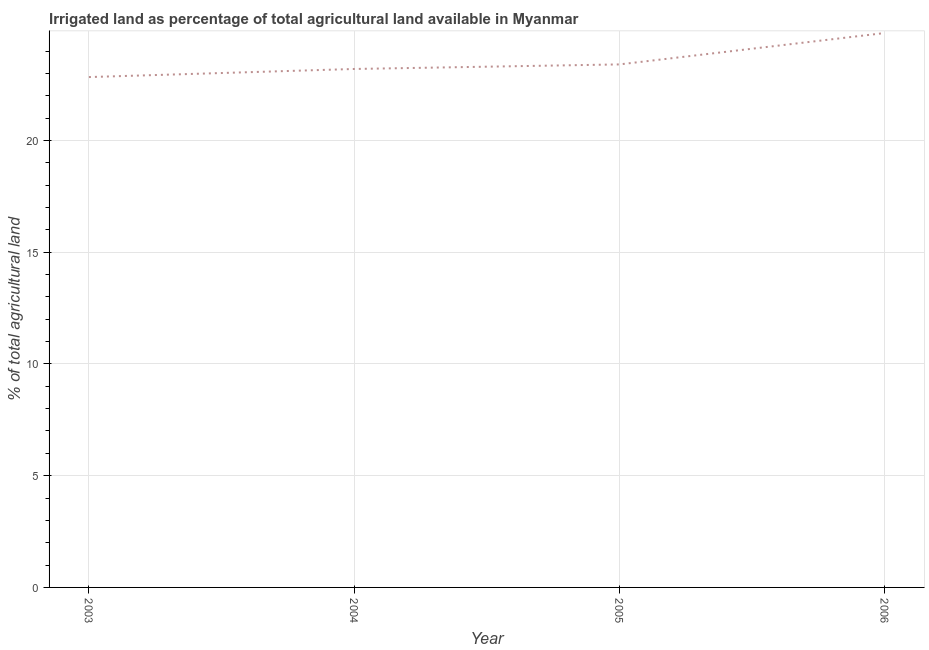What is the percentage of agricultural irrigated land in 2004?
Make the answer very short. 23.2. Across all years, what is the maximum percentage of agricultural irrigated land?
Offer a terse response. 24.81. Across all years, what is the minimum percentage of agricultural irrigated land?
Provide a short and direct response. 22.84. What is the sum of the percentage of agricultural irrigated land?
Ensure brevity in your answer.  94.25. What is the difference between the percentage of agricultural irrigated land in 2004 and 2006?
Offer a terse response. -1.61. What is the average percentage of agricultural irrigated land per year?
Ensure brevity in your answer.  23.56. What is the median percentage of agricultural irrigated land?
Offer a terse response. 23.3. Do a majority of the years between 2004 and 2005 (inclusive) have percentage of agricultural irrigated land greater than 22 %?
Ensure brevity in your answer.  Yes. What is the ratio of the percentage of agricultural irrigated land in 2003 to that in 2004?
Your answer should be compact. 0.98. Is the difference between the percentage of agricultural irrigated land in 2003 and 2004 greater than the difference between any two years?
Your answer should be very brief. No. What is the difference between the highest and the second highest percentage of agricultural irrigated land?
Your answer should be very brief. 1.4. What is the difference between the highest and the lowest percentage of agricultural irrigated land?
Your answer should be compact. 1.97. How many lines are there?
Offer a terse response. 1. What is the difference between two consecutive major ticks on the Y-axis?
Your answer should be very brief. 5. What is the title of the graph?
Your answer should be compact. Irrigated land as percentage of total agricultural land available in Myanmar. What is the label or title of the Y-axis?
Make the answer very short. % of total agricultural land. What is the % of total agricultural land in 2003?
Offer a terse response. 22.84. What is the % of total agricultural land in 2004?
Make the answer very short. 23.2. What is the % of total agricultural land of 2005?
Keep it short and to the point. 23.4. What is the % of total agricultural land in 2006?
Your response must be concise. 24.81. What is the difference between the % of total agricultural land in 2003 and 2004?
Ensure brevity in your answer.  -0.36. What is the difference between the % of total agricultural land in 2003 and 2005?
Provide a succinct answer. -0.57. What is the difference between the % of total agricultural land in 2003 and 2006?
Your answer should be compact. -1.97. What is the difference between the % of total agricultural land in 2004 and 2005?
Ensure brevity in your answer.  -0.2. What is the difference between the % of total agricultural land in 2004 and 2006?
Your response must be concise. -1.61. What is the difference between the % of total agricultural land in 2005 and 2006?
Ensure brevity in your answer.  -1.4. What is the ratio of the % of total agricultural land in 2003 to that in 2006?
Ensure brevity in your answer.  0.92. What is the ratio of the % of total agricultural land in 2004 to that in 2005?
Keep it short and to the point. 0.99. What is the ratio of the % of total agricultural land in 2004 to that in 2006?
Your response must be concise. 0.94. What is the ratio of the % of total agricultural land in 2005 to that in 2006?
Provide a succinct answer. 0.94. 